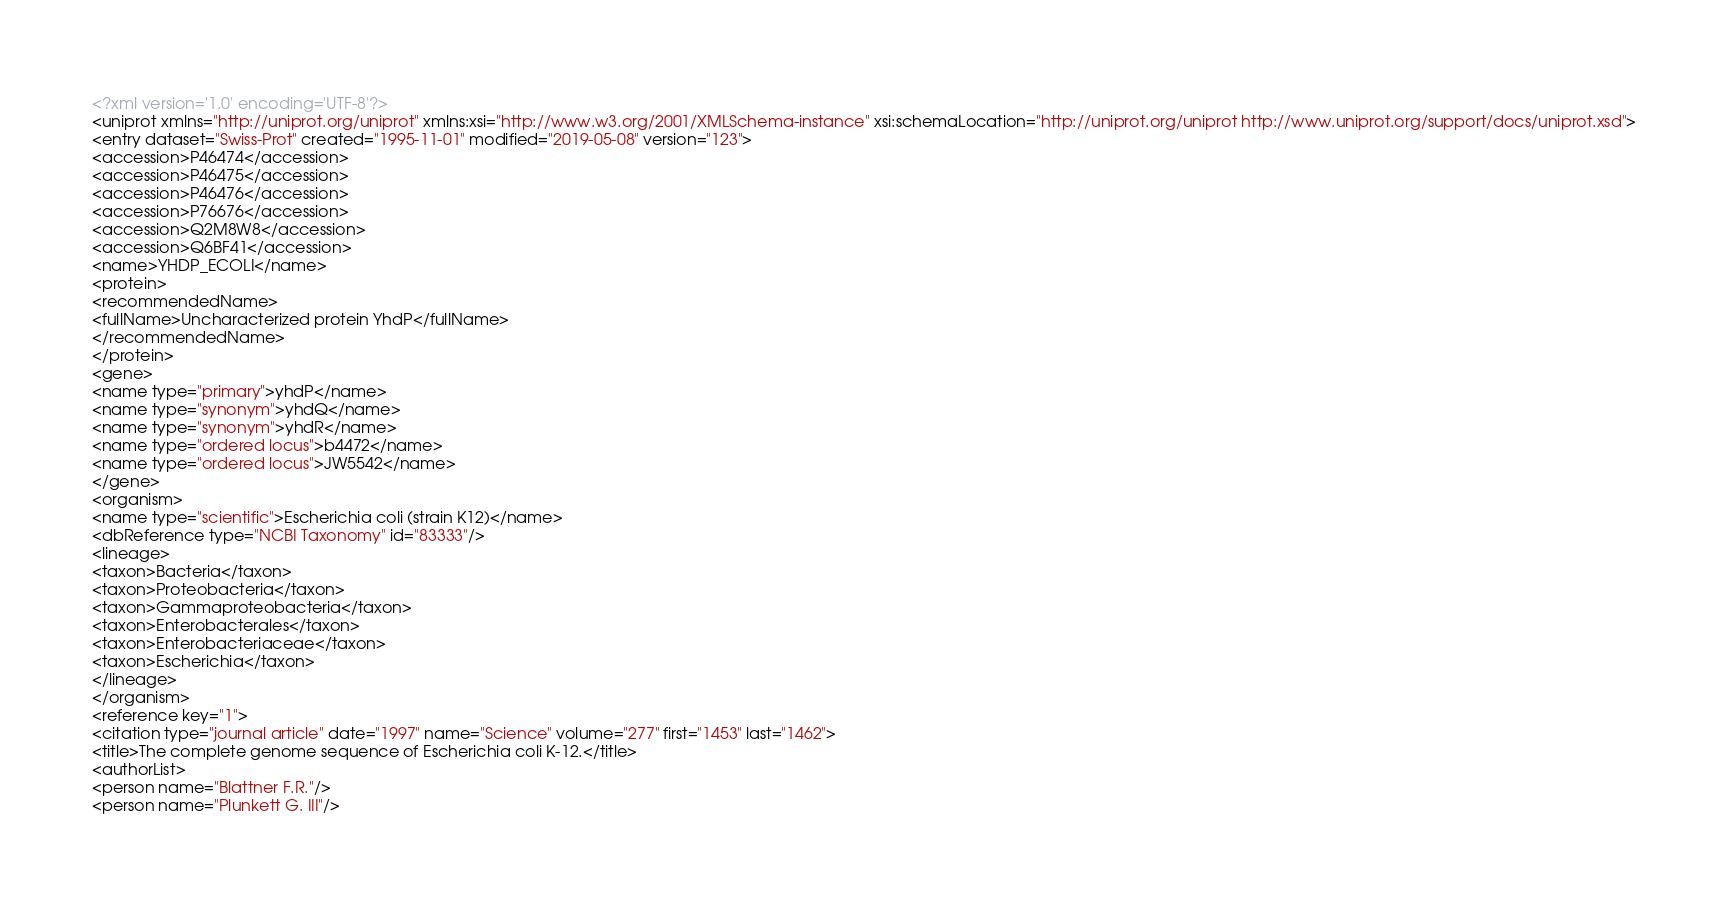<code> <loc_0><loc_0><loc_500><loc_500><_XML_><?xml version='1.0' encoding='UTF-8'?>
<uniprot xmlns="http://uniprot.org/uniprot" xmlns:xsi="http://www.w3.org/2001/XMLSchema-instance" xsi:schemaLocation="http://uniprot.org/uniprot http://www.uniprot.org/support/docs/uniprot.xsd">
<entry dataset="Swiss-Prot" created="1995-11-01" modified="2019-05-08" version="123">
<accession>P46474</accession>
<accession>P46475</accession>
<accession>P46476</accession>
<accession>P76676</accession>
<accession>Q2M8W8</accession>
<accession>Q6BF41</accession>
<name>YHDP_ECOLI</name>
<protein>
<recommendedName>
<fullName>Uncharacterized protein YhdP</fullName>
</recommendedName>
</protein>
<gene>
<name type="primary">yhdP</name>
<name type="synonym">yhdQ</name>
<name type="synonym">yhdR</name>
<name type="ordered locus">b4472</name>
<name type="ordered locus">JW5542</name>
</gene>
<organism>
<name type="scientific">Escherichia coli (strain K12)</name>
<dbReference type="NCBI Taxonomy" id="83333"/>
<lineage>
<taxon>Bacteria</taxon>
<taxon>Proteobacteria</taxon>
<taxon>Gammaproteobacteria</taxon>
<taxon>Enterobacterales</taxon>
<taxon>Enterobacteriaceae</taxon>
<taxon>Escherichia</taxon>
</lineage>
</organism>
<reference key="1">
<citation type="journal article" date="1997" name="Science" volume="277" first="1453" last="1462">
<title>The complete genome sequence of Escherichia coli K-12.</title>
<authorList>
<person name="Blattner F.R."/>
<person name="Plunkett G. III"/></code> 